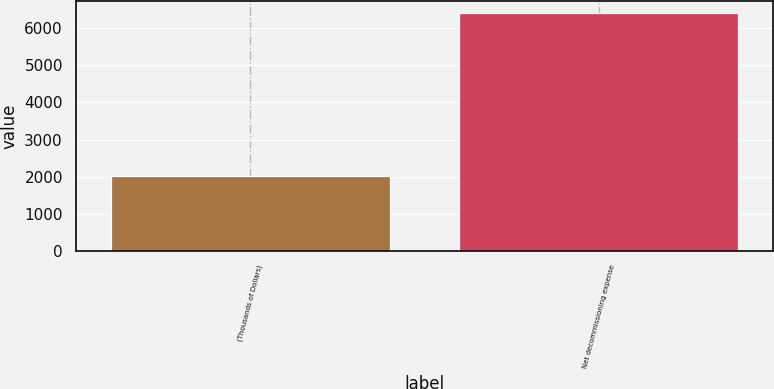Convert chart. <chart><loc_0><loc_0><loc_500><loc_500><bar_chart><fcel>(Thousands of Dollars)<fcel>Net decommissioning expense<nl><fcel>2013<fcel>6402<nl></chart> 